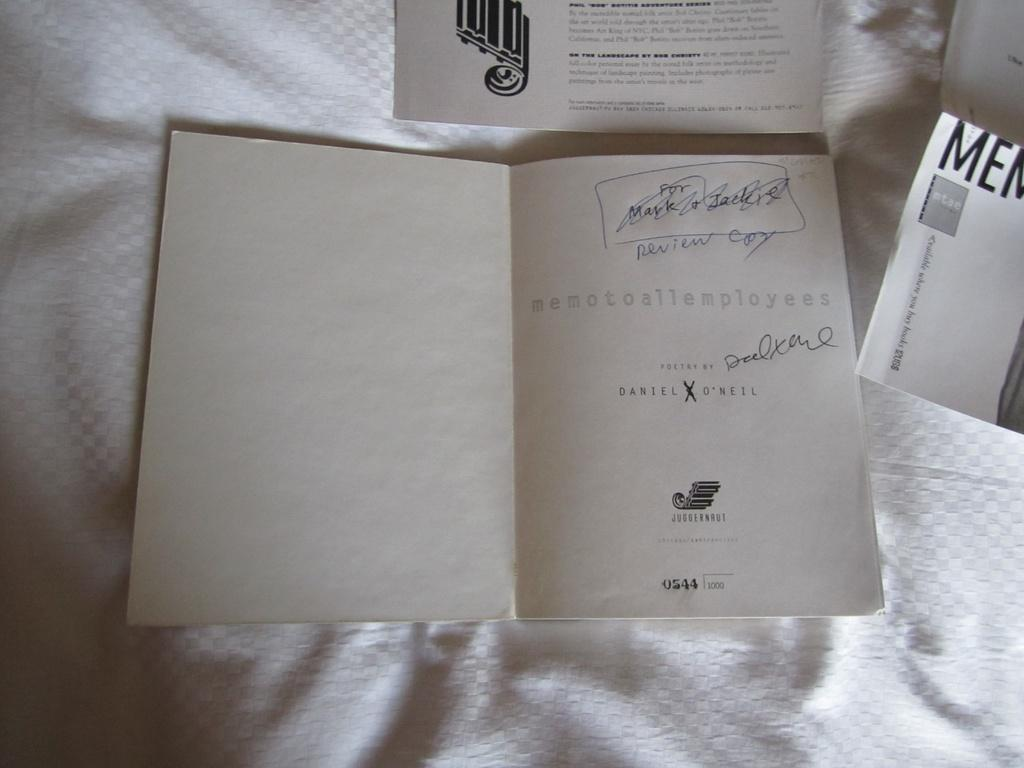What objects can be seen in the image? There are papers in the image. Can you describe the papers in more detail? Unfortunately, the provided facts do not offer any additional details about the papers. Are there any other objects or subjects in the image besides the papers? No additional information is provided about other objects or subjects in the image. What type of books can be seen in the image? There are no books present in the image; only papers are mentioned. Is the band playing in the bathtub in the image? There is no mention of a band or a bathtub in the image, so this question cannot be answered definitively. 